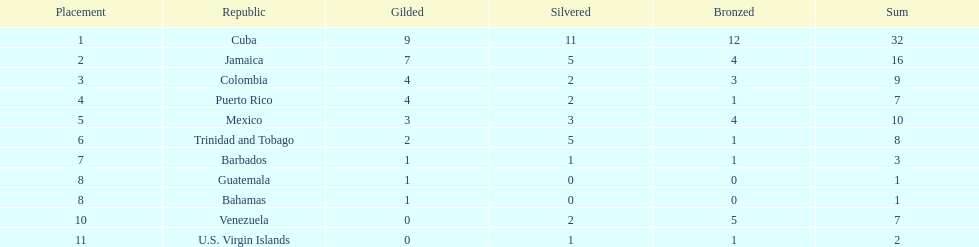Which team had four gold models and one bronze medal? Puerto Rico. Parse the table in full. {'header': ['Placement', 'Republic', 'Gilded', 'Silvered', 'Bronzed', 'Sum'], 'rows': [['1', 'Cuba', '9', '11', '12', '32'], ['2', 'Jamaica', '7', '5', '4', '16'], ['3', 'Colombia', '4', '2', '3', '9'], ['4', 'Puerto Rico', '4', '2', '1', '7'], ['5', 'Mexico', '3', '3', '4', '10'], ['6', 'Trinidad and Tobago', '2', '5', '1', '8'], ['7', 'Barbados', '1', '1', '1', '3'], ['8', 'Guatemala', '1', '0', '0', '1'], ['8', 'Bahamas', '1', '0', '0', '1'], ['10', 'Venezuela', '0', '2', '5', '7'], ['11', 'U.S. Virgin Islands', '0', '1', '1', '2']]} 